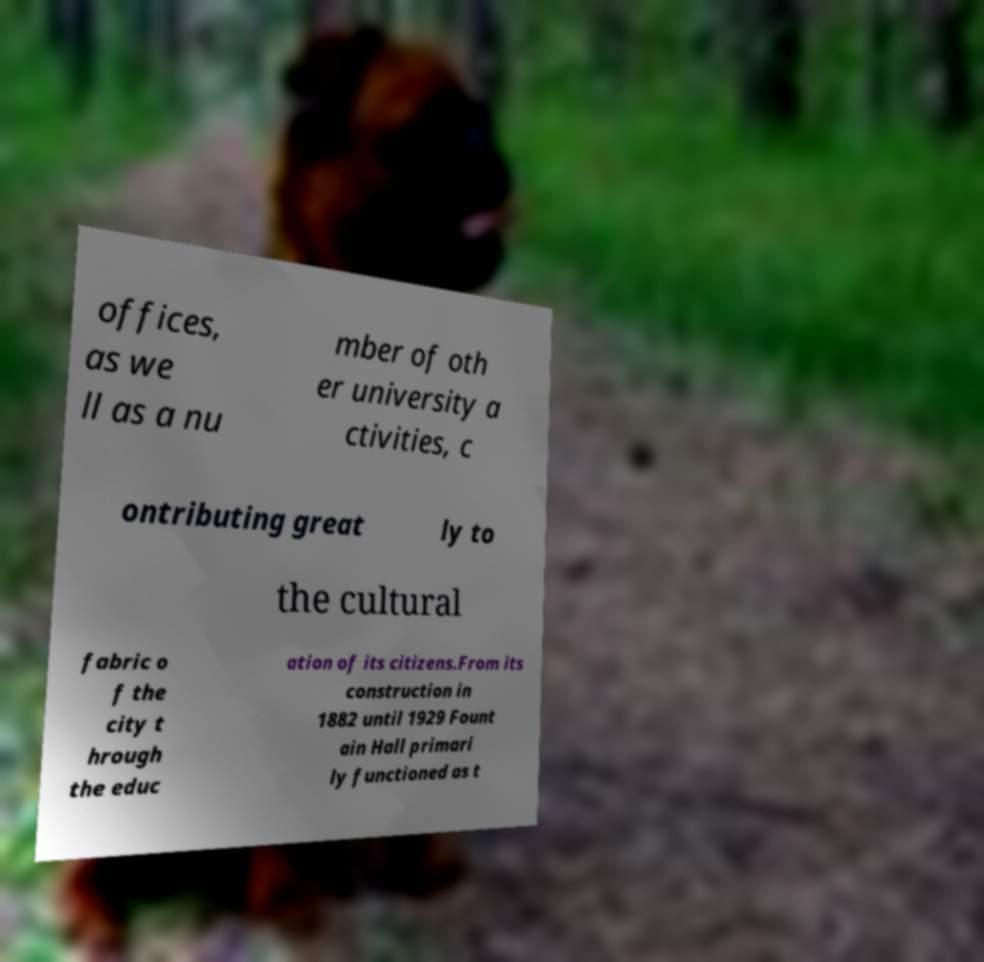Can you read and provide the text displayed in the image?This photo seems to have some interesting text. Can you extract and type it out for me? offices, as we ll as a nu mber of oth er university a ctivities, c ontributing great ly to the cultural fabric o f the city t hrough the educ ation of its citizens.From its construction in 1882 until 1929 Fount ain Hall primari ly functioned as t 